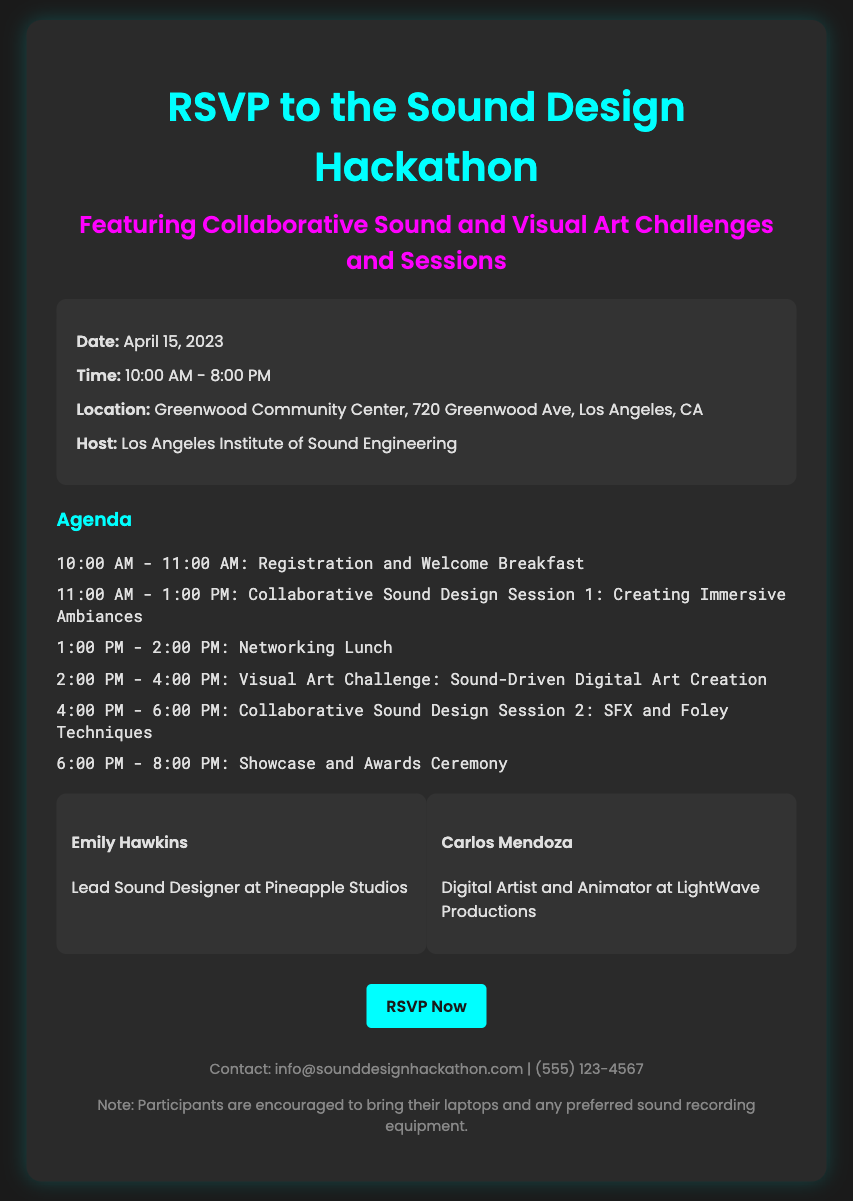qual é a data do evento? A data do evento é mencionada na seção de informações e é o dia em que o hackathon acontecerá.
Answer: April 15, 2023 qual é o horário do evento? O horário do evento está especificado na seção de informações, indicando quando começará e terminará.
Answer: 10:00 AM - 8:00 PM onde será realizado o evento? A localização do evento é fornecida na seção de informações, descrevendo o endereço completo.
Answer: Greenwood Community Center, 720 Greenwood Ave, Los Angeles, CA quem são os palestrantes do evento? Os palestrantes são listados na seção de palestrantes, incluindo seus nomes e cargos.
Answer: Emily Hawkins e Carlos Mendoza quais são os tópicos da agenda? Os tópicos da agenda são listados em uma lista que detalha as atividades e horários do dia do evento.
Answer: Registro e Welcome Breakfast, Collaborative Sound Design Session 1, Networking Lunch, Visual Art Challenge, Collaborative Sound Design Session 2, Showcase and Awards Ceremony qual é a organização que hospeda o evento? A organização que está organizando o evento é mencionada na seção de informações.
Answer: Los Angeles Institute of Sound Engineering quais equipamentos os participantes devem trazer? A nota final na seção de rodapé menciona o equipamento recomendado para os participantes trazerem.
Answer: Laptops e qualquer equipamento de gravação de som preferido qual é o site para RSVP? O link para o RSVP é fornecido na chamada para ação, onde as pessoas podem se inscrever para o evento.
Answer: https://www.sounddesignhackathon.com/rsvp 